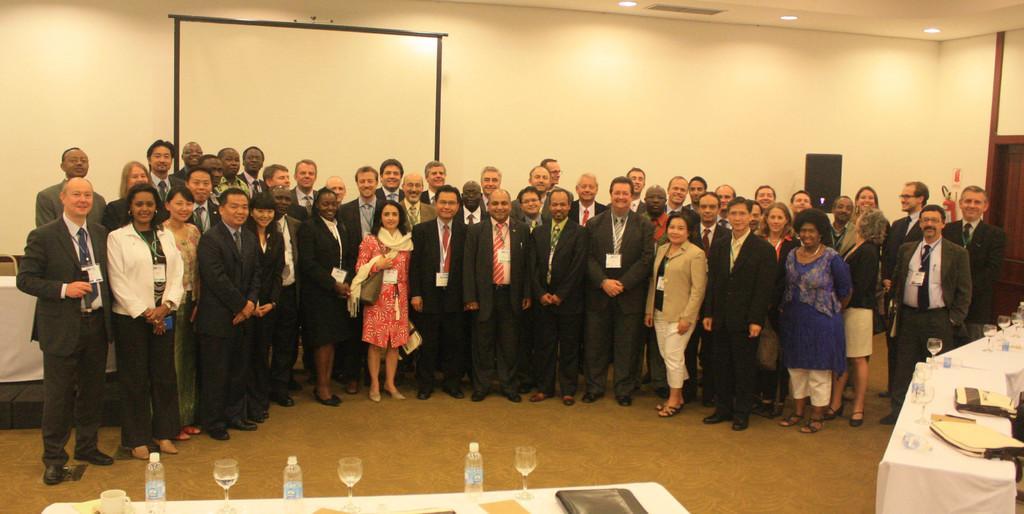Could you give a brief overview of what you see in this image? In the picture we can see some group of people standing in a closed room posing for a photograph, in the foreground of the picture there are some glasses, bottles, books on the tables and in the background of the picture there is projector screen, sound box, there is a wall. 